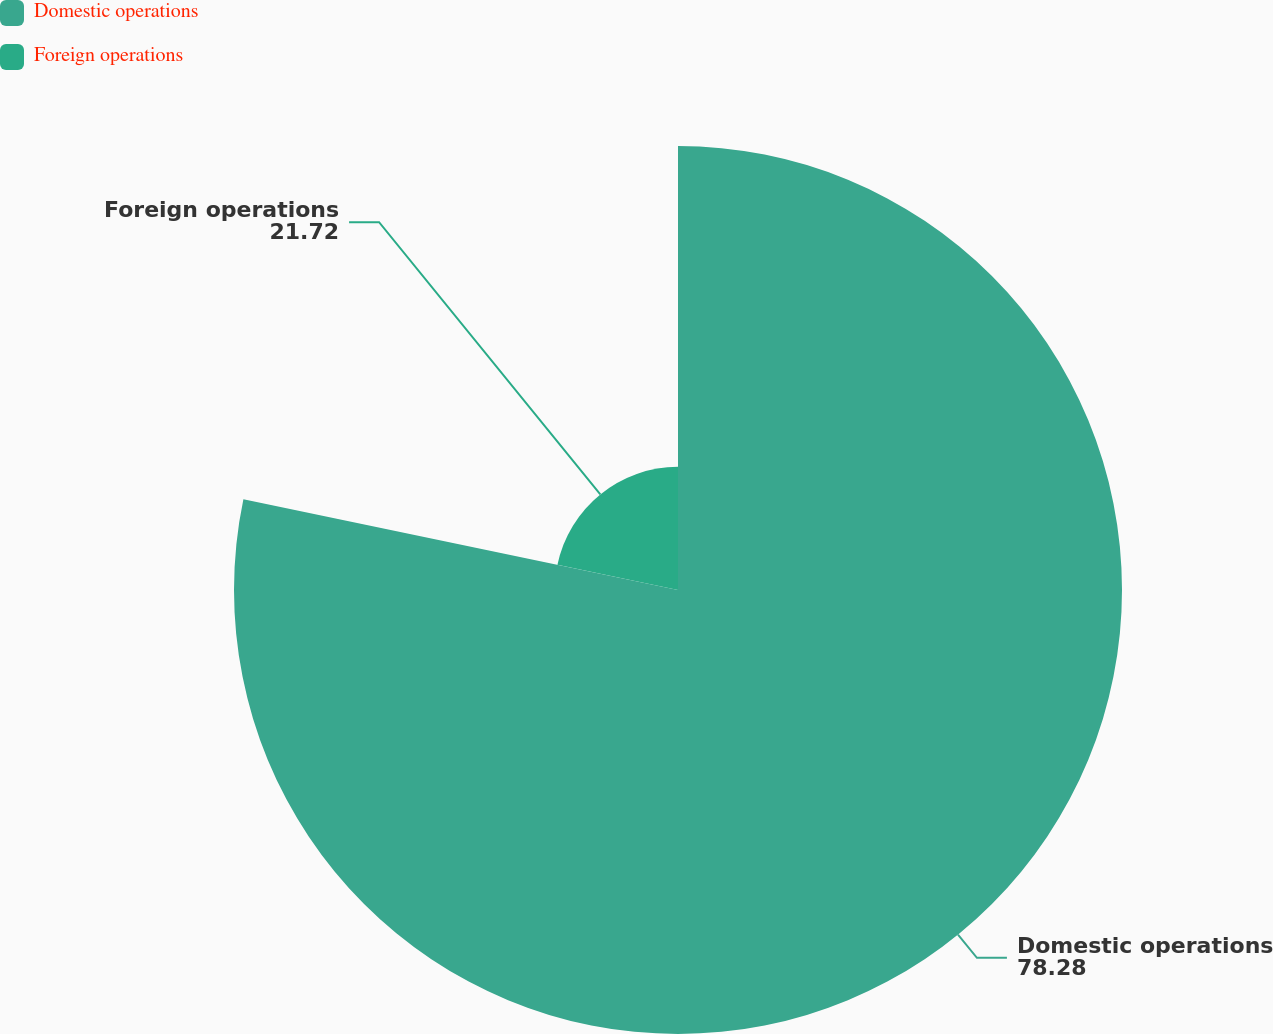<chart> <loc_0><loc_0><loc_500><loc_500><pie_chart><fcel>Domestic operations<fcel>Foreign operations<nl><fcel>78.28%<fcel>21.72%<nl></chart> 